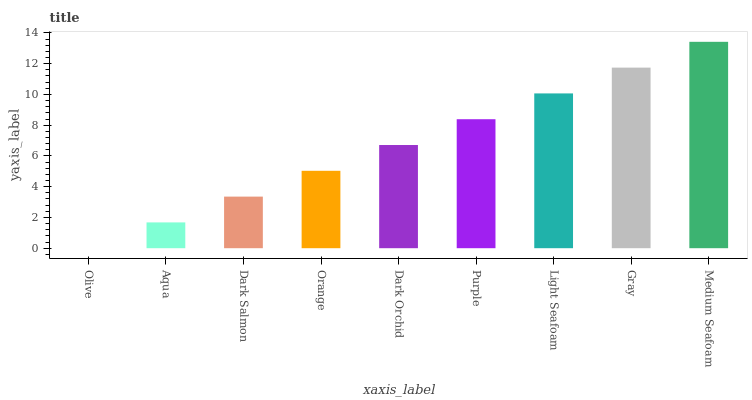Is Aqua the minimum?
Answer yes or no. No. Is Aqua the maximum?
Answer yes or no. No. Is Aqua greater than Olive?
Answer yes or no. Yes. Is Olive less than Aqua?
Answer yes or no. Yes. Is Olive greater than Aqua?
Answer yes or no. No. Is Aqua less than Olive?
Answer yes or no. No. Is Dark Orchid the high median?
Answer yes or no. Yes. Is Dark Orchid the low median?
Answer yes or no. Yes. Is Orange the high median?
Answer yes or no. No. Is Medium Seafoam the low median?
Answer yes or no. No. 